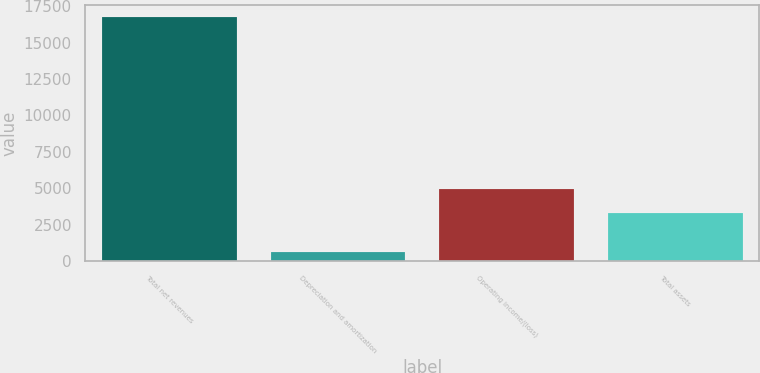Convert chart. <chart><loc_0><loc_0><loc_500><loc_500><bar_chart><fcel>Total net revenues<fcel>Depreciation and amortization<fcel>Operating income/(loss)<fcel>Total assets<nl><fcel>16732.2<fcel>638.3<fcel>4936.59<fcel>3327.2<nl></chart> 